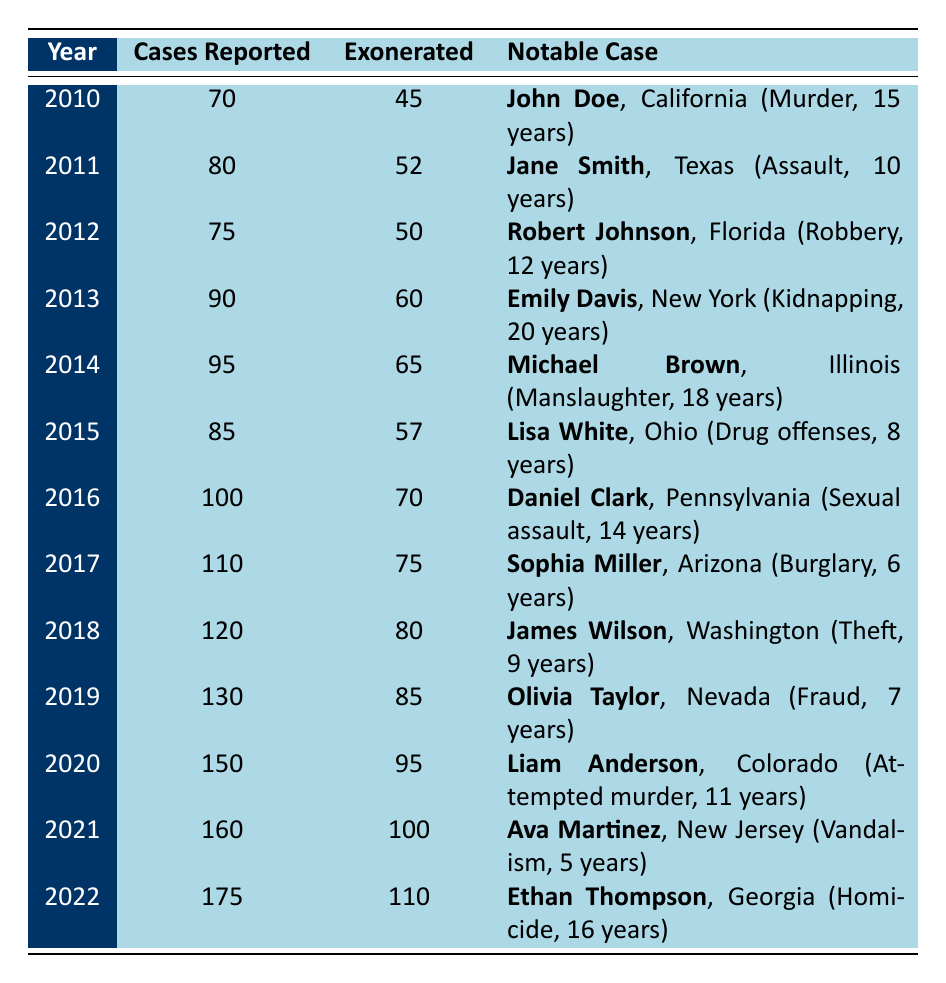What was the highest number of cases reported in a year? The table lists the cases reported per year from 2010 to 2022. The highest number is found in 2022, where 175 cases were reported.
Answer: 175 Which year had the most exonerations? By reviewing the table, 2022 shows the highest number of exonerations at 110.
Answer: 110 What is the average number of cases reported per year from 2010 to 2022? To calculate the average, we first sum the cases reported: 70 + 80 + 75 + 90 + 95 + 85 + 100 + 110 + 120 + 130 + 150 + 160 + 175 = 1,435. Then, divide by the number of years (13), which results in 1,435 / 13 = approximately 110.38.
Answer: Approximately 110.38 In how many years were more than 80 cases exonerated? The table shows years where the exonerated count was over 80: 2018 (80), 2019 (85), 2020 (95), 2021 (100), and 2022 (110), totaling 5 years.
Answer: 5 Was there a year with more reported cases than exonerated? By looking at each year, all years where cases reported exceed exonerated are 2010 (70 cases, 45 exonerated), 2015 (85 cases, 57 exonerated), and 2016 (100 cases, 70 exonerated). Thus, yes, there were years with more reported cases than exonerations.
Answer: Yes What is the difference in the number of exonerated cases between 2010 and 2022? The exonerated cases in 2010 is 45 and in 2022 is 110. The difference is calculated as 110 - 45, which equals 65.
Answer: 65 How many notable cases involved crimes related to theft between 2010 and 2022? The table shows one notable case involving theft, which is James Wilson in 2018.
Answer: 1 Which state had the most notable cases listed within the given years? Analyzing the table, different states appear with notable cases, but no state repeats; hence, each state has one case listed. Therefore, no state stands out in terms of the number of notable cases.
Answer: None What trend can be observed in the number of cases exonerated from 2010 to 2022? By observing the data, there is a steady increase in the number of exonerated cases each year, starting from 45 in 2010 and reaching 110 in 2022, indicating a trend towards more successful exonerations over time.
Answer: Increasing trend How many years had exonerated cases that were less than 60? The years 2010 (45), 2011 (52), and 2015 (57) had exonerated cases less than 60, totaling 3 years.
Answer: 3 What was the average duration served by exonerated individuals in notable cases from 2010 to 2022? The total years served by notable cases can be summed: 15 + 10 + 12 + 20 + 18 + 8 + 14 + 6 + 9 + 7 + 11 + 5 + 16 =  141 years. There are 13 cases, so the average is 141 / 13 = approximately 10.85 years.
Answer: Approximately 10.85 years 